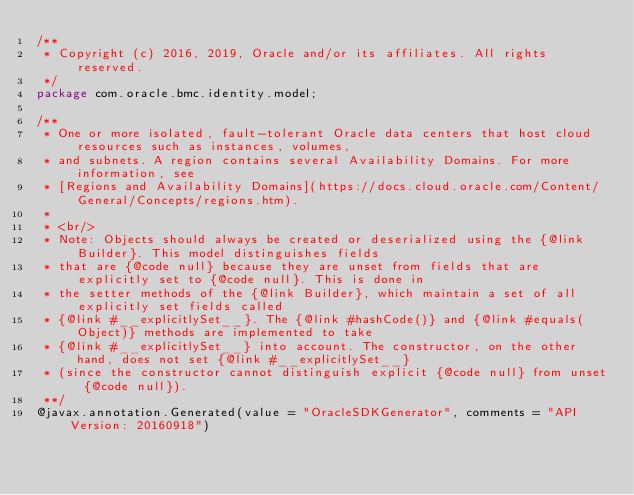<code> <loc_0><loc_0><loc_500><loc_500><_Java_>/**
 * Copyright (c) 2016, 2019, Oracle and/or its affiliates. All rights reserved.
 */
package com.oracle.bmc.identity.model;

/**
 * One or more isolated, fault-tolerant Oracle data centers that host cloud resources such as instances, volumes,
 * and subnets. A region contains several Availability Domains. For more information, see
 * [Regions and Availability Domains](https://docs.cloud.oracle.com/Content/General/Concepts/regions.htm).
 *
 * <br/>
 * Note: Objects should always be created or deserialized using the {@link Builder}. This model distinguishes fields
 * that are {@code null} because they are unset from fields that are explicitly set to {@code null}. This is done in
 * the setter methods of the {@link Builder}, which maintain a set of all explicitly set fields called
 * {@link #__explicitlySet__}. The {@link #hashCode()} and {@link #equals(Object)} methods are implemented to take
 * {@link #__explicitlySet__} into account. The constructor, on the other hand, does not set {@link #__explicitlySet__}
 * (since the constructor cannot distinguish explicit {@code null} from unset {@code null}).
 **/
@javax.annotation.Generated(value = "OracleSDKGenerator", comments = "API Version: 20160918")</code> 